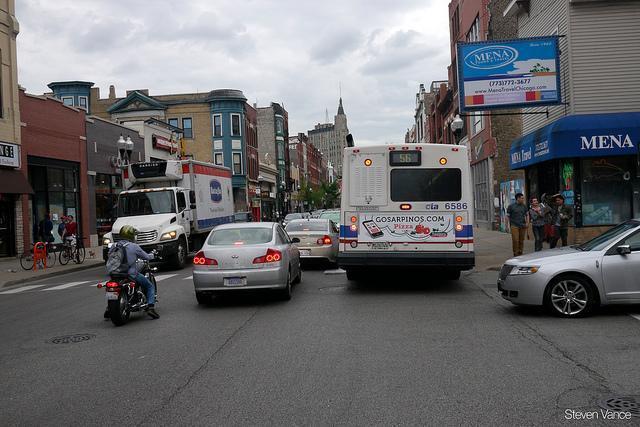How many deckers is the bus?
Give a very brief answer. 1. How many cars are there?
Give a very brief answer. 2. How many giraffes are there?
Give a very brief answer. 0. 